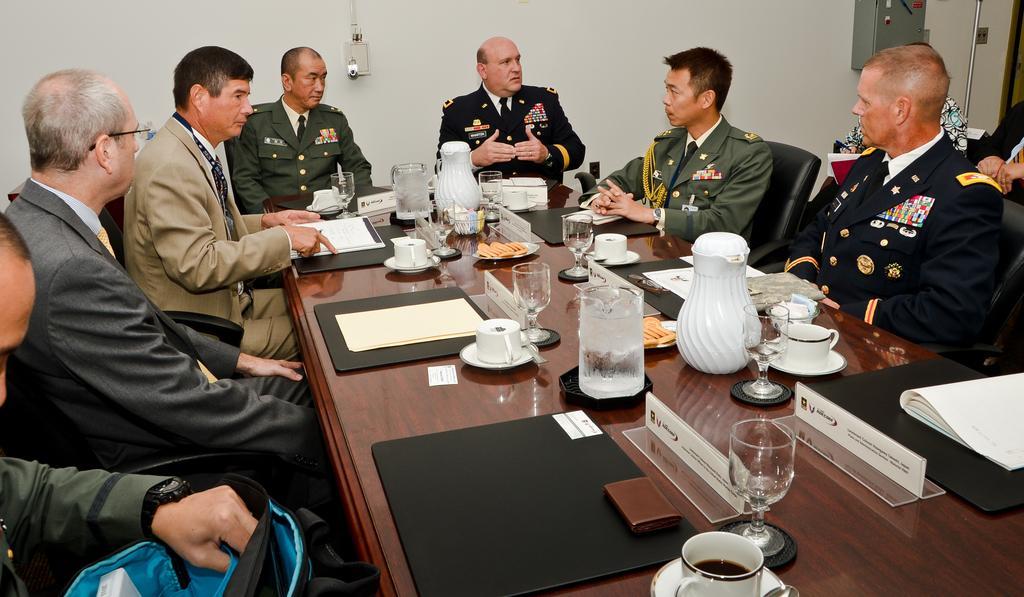Could you give a brief overview of what you see in this image? This is a conference room. Here we can see few men sitting on the chairs in front of a table and talking something and on the table we can see files, boards, jars, cup and saucers, and a plate of biscuits and also glasses. On the background we can see a wall. 